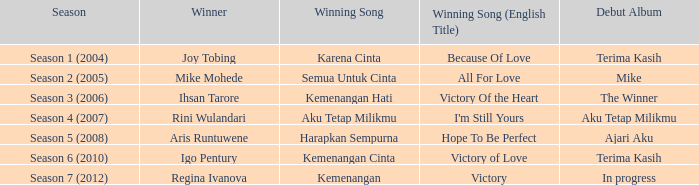Who won with the song kemenangan cinta? Igo Pentury. 